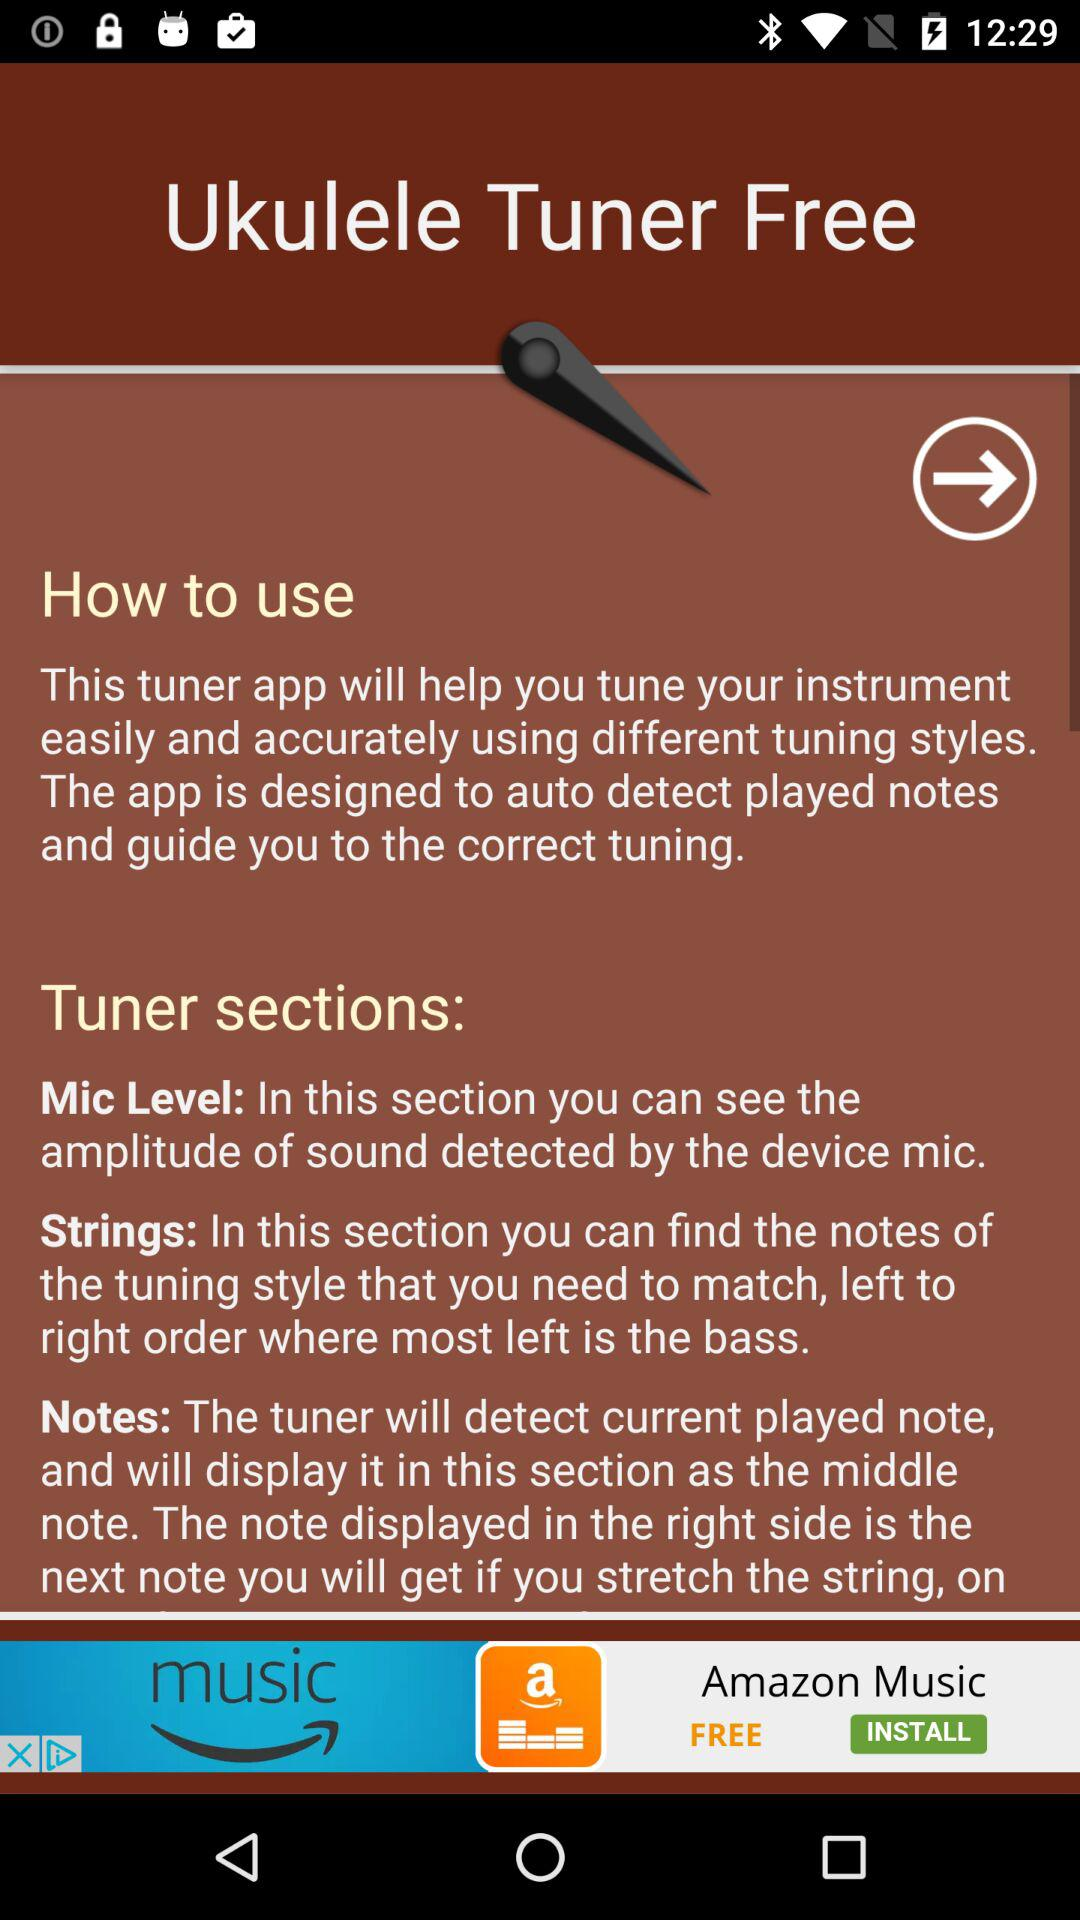How does the "Ukulele Tuner" application help? The "Ukulele Tuner" application helps tune your instrument easily and accurately using different tuning styles. The app is designed to auto-detect played notes and guide you to the correct tuning. 